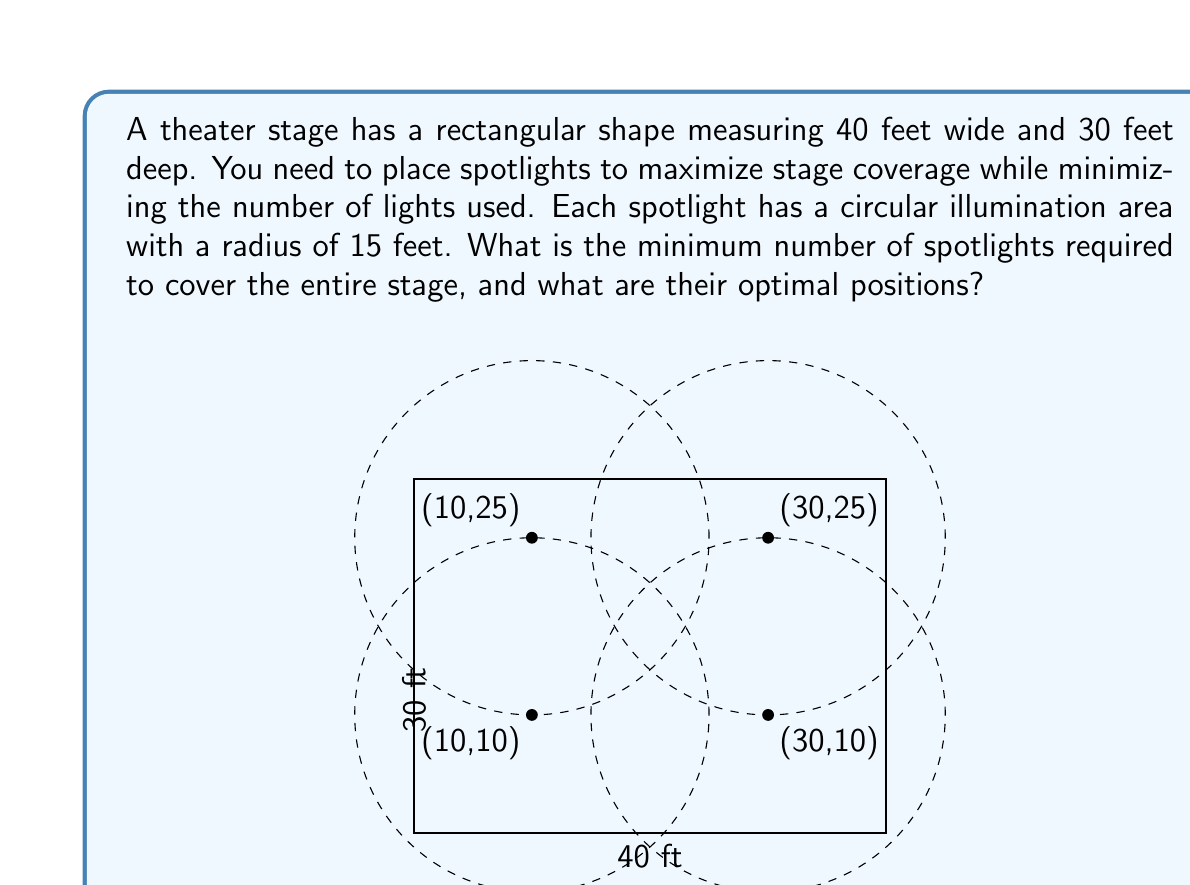Help me with this question. To solve this problem, we need to follow these steps:

1. Determine the area of the stage:
   Area of stage = $40 \text{ ft} \times 30 \text{ ft} = 1200 \text{ sq ft}$

2. Calculate the area covered by one spotlight:
   Area of one spotlight = $\pi r^2 = \pi (15 \text{ ft})^2 = 225\pi \approx 706.86 \text{ sq ft}$

3. Theoretically, we need:
   $\frac{1200 \text{ sq ft}}{706.86 \text{ sq ft}} \approx 1.70$ spotlights

   However, we can't use a fractional number of spotlights, so we need to round up to the nearest whole number.

4. The minimum number of spotlights required is 4.

5. To optimize the placement, we need to position the spotlights to cover the corners and edges of the stage. The best arrangement is to place the spotlights in a rectangular pattern:

   - Spotlight 1: (10 ft, 10 ft)
   - Spotlight 2: (30 ft, 10 ft)
   - Spotlight 3: (10 ft, 25 ft)
   - Spotlight 4: (30 ft, 25 ft)

This arrangement ensures that:
- The corners are covered
- The edges are fully illuminated
- There is sufficient overlap in the center to avoid dark spots

We can verify this placement mathematically:

- The distance between adjacent spotlights horizontally is 20 ft, which is less than twice the radius (30 ft), ensuring overlap.
- The distance between adjacent spotlights vertically is 15 ft, which is equal to the radius, ensuring perfect coverage.
- The distance from each spotlight to the nearest edge is 10 ft or 5 ft, both of which are less than the 15 ft radius, ensuring full coverage of the edges.

This arrangement provides complete coverage of the 40 ft × 30 ft stage using the minimum number of spotlights.
Answer: The minimum number of spotlights required is 4, positioned at coordinates (10, 10), (30, 10), (10, 25), and (30, 25) in feet from the bottom-left corner of the stage. 